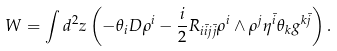Convert formula to latex. <formula><loc_0><loc_0><loc_500><loc_500>W = \int d ^ { 2 } z \left ( - \theta _ { i } D \rho ^ { i } - \frac { i } { 2 } R _ { i \bar { i } j \bar { j } } \rho ^ { i } \wedge \rho ^ { j } \eta ^ { \bar { i } } \theta _ { k } g ^ { k \bar { j } } \right ) .</formula> 